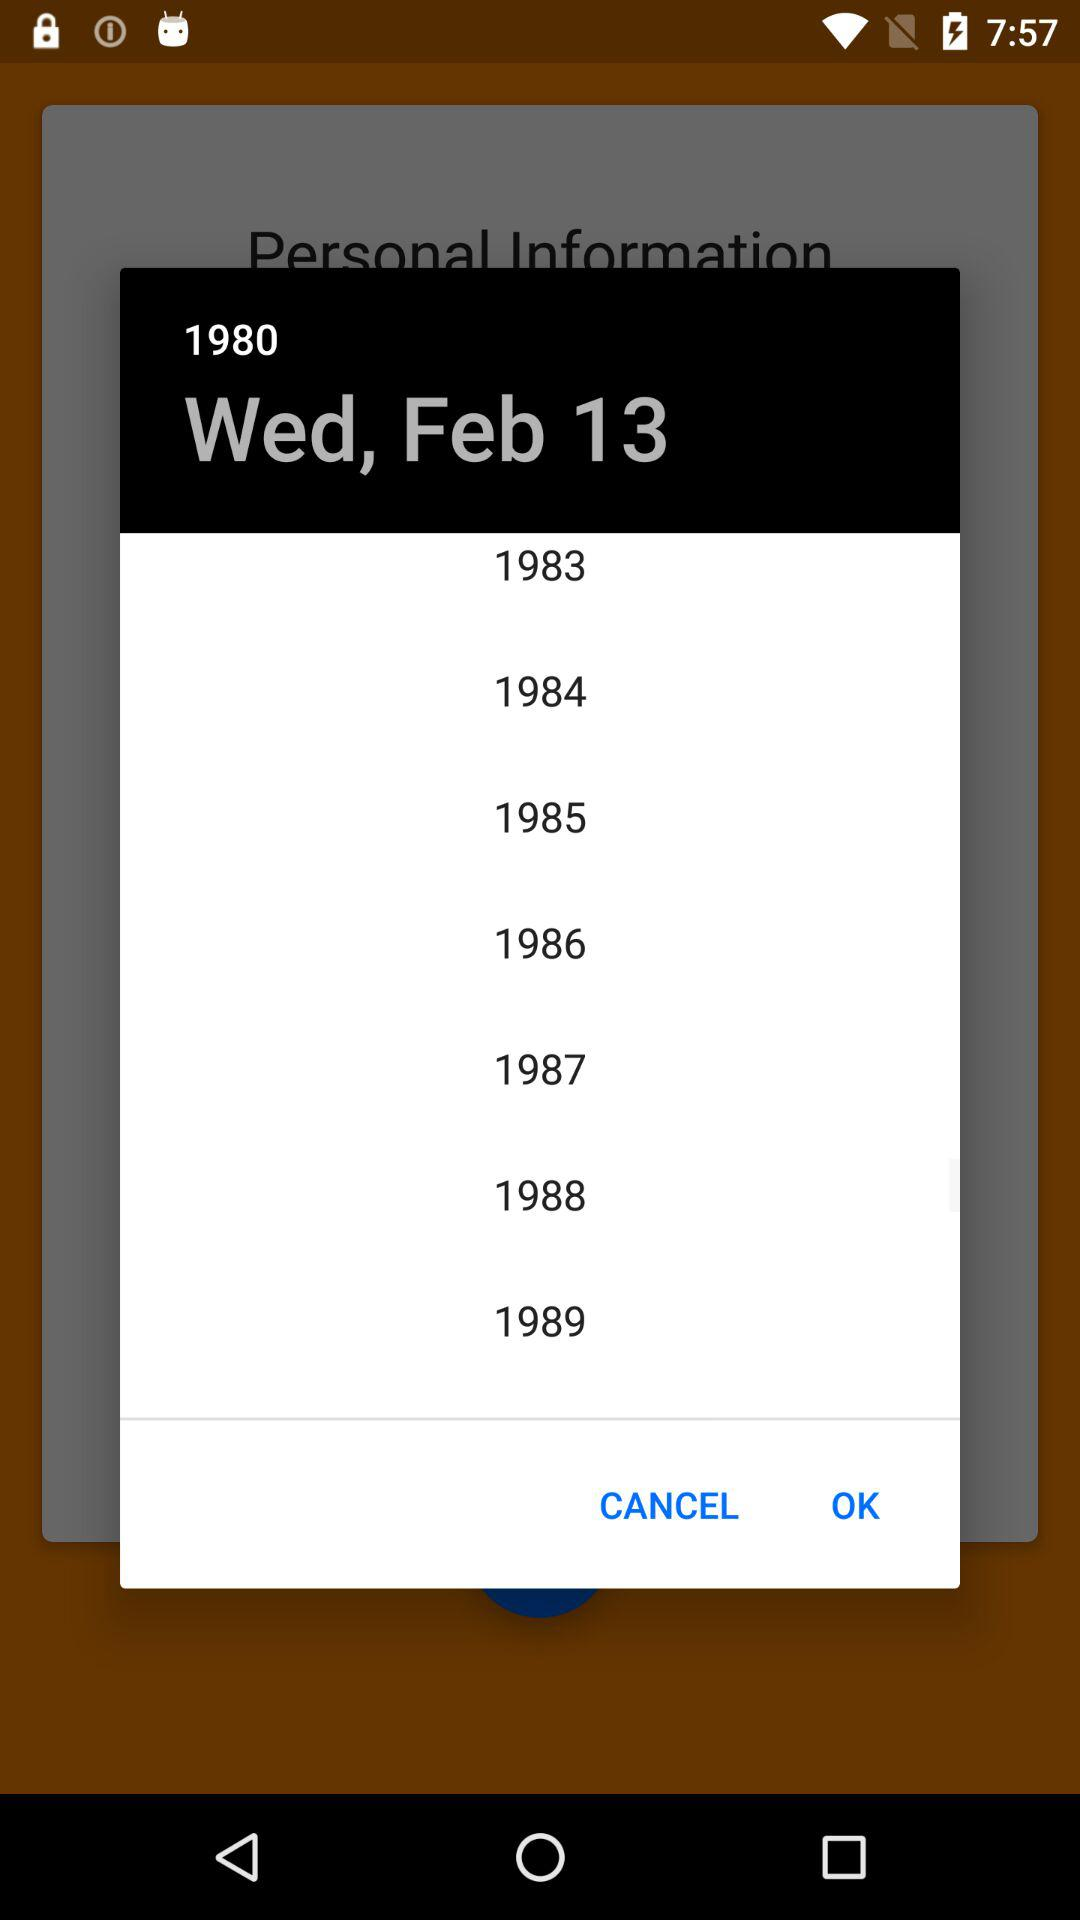What is the day on February 13? The day on February 13 is Wednesday. 